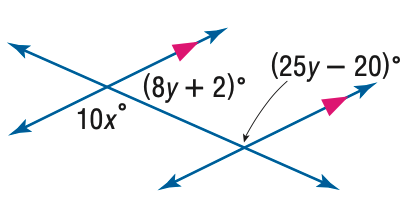Answer the mathemtical geometry problem and directly provide the correct option letter.
Question: Find x in the figure.
Choices: A: 6 B: 12 C: 13 D: 14 C 